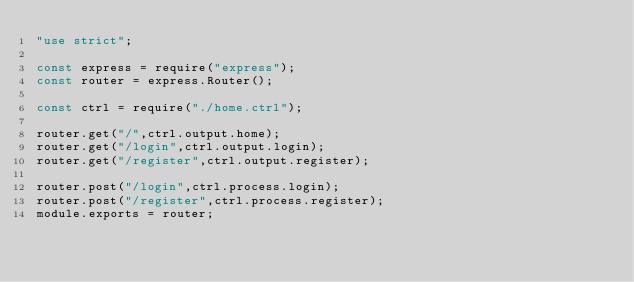Convert code to text. <code><loc_0><loc_0><loc_500><loc_500><_JavaScript_>"use strict";

const express = require("express");
const router = express.Router();

const ctrl = require("./home.ctrl");

router.get("/",ctrl.output.home);
router.get("/login",ctrl.output.login);
router.get("/register",ctrl.output.register);

router.post("/login",ctrl.process.login);
router.post("/register",ctrl.process.register);
module.exports = router;</code> 